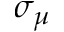Convert formula to latex. <formula><loc_0><loc_0><loc_500><loc_500>\sigma _ { \mu }</formula> 